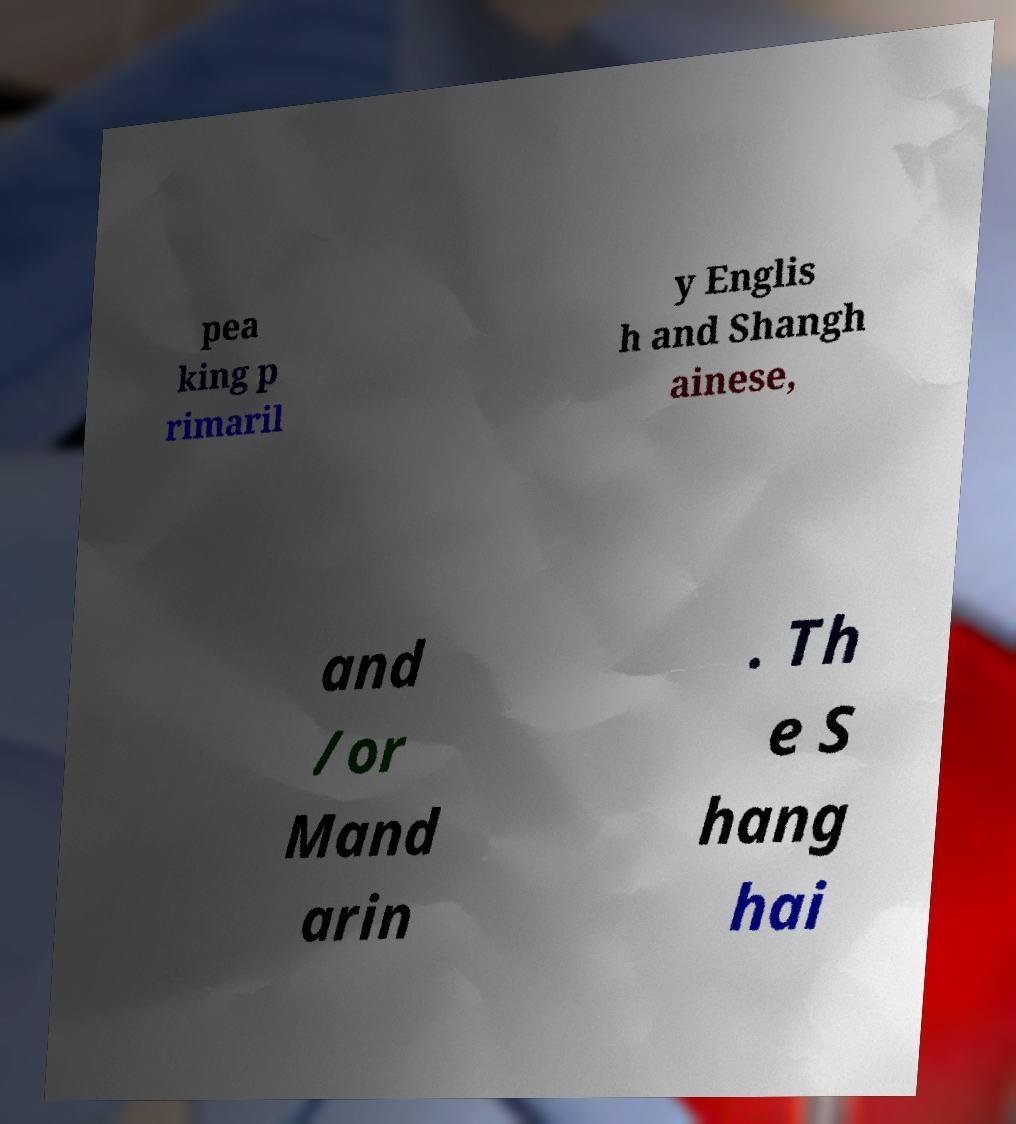There's text embedded in this image that I need extracted. Can you transcribe it verbatim? pea king p rimaril y Englis h and Shangh ainese, and /or Mand arin . Th e S hang hai 